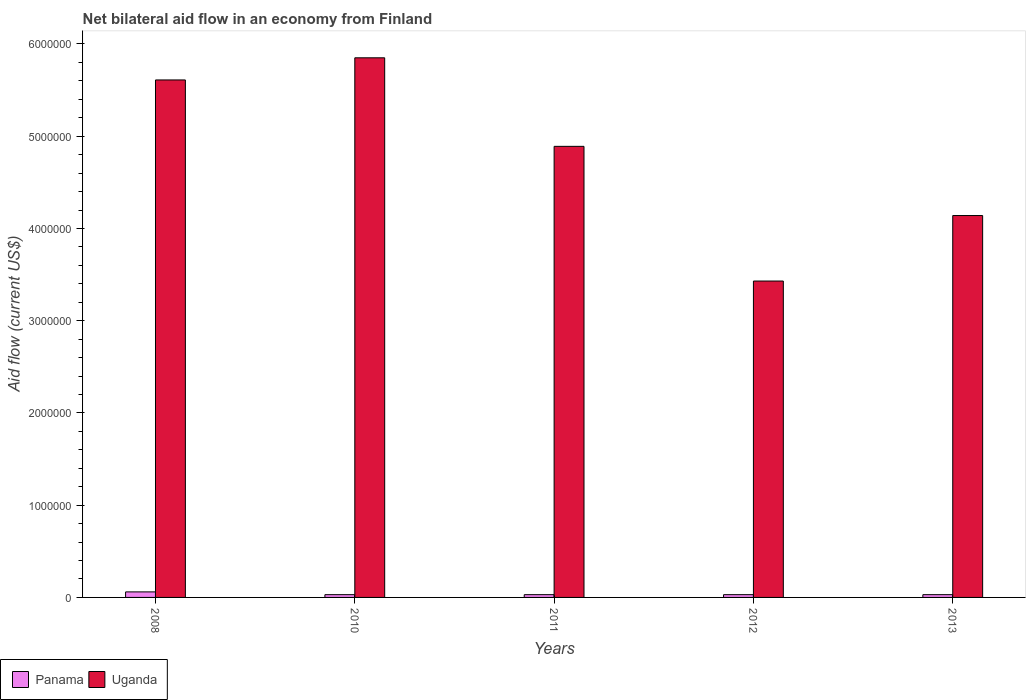How many different coloured bars are there?
Offer a very short reply. 2. How many groups of bars are there?
Ensure brevity in your answer.  5. Are the number of bars per tick equal to the number of legend labels?
Make the answer very short. Yes. How many bars are there on the 2nd tick from the right?
Provide a short and direct response. 2. What is the net bilateral aid flow in Uganda in 2011?
Provide a succinct answer. 4.89e+06. Across all years, what is the maximum net bilateral aid flow in Panama?
Make the answer very short. 6.00e+04. Across all years, what is the minimum net bilateral aid flow in Uganda?
Offer a very short reply. 3.43e+06. In which year was the net bilateral aid flow in Uganda minimum?
Your answer should be compact. 2012. What is the total net bilateral aid flow in Uganda in the graph?
Provide a short and direct response. 2.39e+07. What is the difference between the net bilateral aid flow in Panama in 2011 and the net bilateral aid flow in Uganda in 2012?
Provide a succinct answer. -3.40e+06. What is the average net bilateral aid flow in Uganda per year?
Provide a succinct answer. 4.78e+06. In the year 2012, what is the difference between the net bilateral aid flow in Uganda and net bilateral aid flow in Panama?
Your answer should be very brief. 3.40e+06. In how many years, is the net bilateral aid flow in Uganda greater than 5400000 US$?
Offer a terse response. 2. What is the ratio of the net bilateral aid flow in Uganda in 2011 to that in 2012?
Offer a very short reply. 1.43. Is the net bilateral aid flow in Uganda in 2010 less than that in 2012?
Your answer should be compact. No. Is the difference between the net bilateral aid flow in Uganda in 2012 and 2013 greater than the difference between the net bilateral aid flow in Panama in 2012 and 2013?
Make the answer very short. No. What is the difference between the highest and the second highest net bilateral aid flow in Uganda?
Ensure brevity in your answer.  2.40e+05. In how many years, is the net bilateral aid flow in Uganda greater than the average net bilateral aid flow in Uganda taken over all years?
Your answer should be very brief. 3. What does the 2nd bar from the left in 2008 represents?
Offer a terse response. Uganda. What does the 1st bar from the right in 2012 represents?
Offer a terse response. Uganda. How many bars are there?
Give a very brief answer. 10. How many years are there in the graph?
Provide a succinct answer. 5. What is the difference between two consecutive major ticks on the Y-axis?
Make the answer very short. 1.00e+06. Are the values on the major ticks of Y-axis written in scientific E-notation?
Your response must be concise. No. Does the graph contain any zero values?
Provide a succinct answer. No. How are the legend labels stacked?
Keep it short and to the point. Horizontal. What is the title of the graph?
Give a very brief answer. Net bilateral aid flow in an economy from Finland. What is the label or title of the X-axis?
Keep it short and to the point. Years. What is the Aid flow (current US$) of Panama in 2008?
Your response must be concise. 6.00e+04. What is the Aid flow (current US$) of Uganda in 2008?
Ensure brevity in your answer.  5.61e+06. What is the Aid flow (current US$) of Panama in 2010?
Provide a succinct answer. 3.00e+04. What is the Aid flow (current US$) in Uganda in 2010?
Your answer should be compact. 5.85e+06. What is the Aid flow (current US$) in Uganda in 2011?
Give a very brief answer. 4.89e+06. What is the Aid flow (current US$) in Uganda in 2012?
Make the answer very short. 3.43e+06. What is the Aid flow (current US$) of Uganda in 2013?
Make the answer very short. 4.14e+06. Across all years, what is the maximum Aid flow (current US$) of Uganda?
Give a very brief answer. 5.85e+06. Across all years, what is the minimum Aid flow (current US$) in Panama?
Your answer should be compact. 3.00e+04. Across all years, what is the minimum Aid flow (current US$) in Uganda?
Provide a succinct answer. 3.43e+06. What is the total Aid flow (current US$) of Uganda in the graph?
Offer a very short reply. 2.39e+07. What is the difference between the Aid flow (current US$) of Panama in 2008 and that in 2010?
Ensure brevity in your answer.  3.00e+04. What is the difference between the Aid flow (current US$) of Uganda in 2008 and that in 2010?
Your answer should be very brief. -2.40e+05. What is the difference between the Aid flow (current US$) of Uganda in 2008 and that in 2011?
Give a very brief answer. 7.20e+05. What is the difference between the Aid flow (current US$) in Panama in 2008 and that in 2012?
Your answer should be compact. 3.00e+04. What is the difference between the Aid flow (current US$) in Uganda in 2008 and that in 2012?
Your response must be concise. 2.18e+06. What is the difference between the Aid flow (current US$) in Uganda in 2008 and that in 2013?
Your response must be concise. 1.47e+06. What is the difference between the Aid flow (current US$) in Uganda in 2010 and that in 2011?
Make the answer very short. 9.60e+05. What is the difference between the Aid flow (current US$) of Panama in 2010 and that in 2012?
Your response must be concise. 0. What is the difference between the Aid flow (current US$) in Uganda in 2010 and that in 2012?
Make the answer very short. 2.42e+06. What is the difference between the Aid flow (current US$) in Panama in 2010 and that in 2013?
Your answer should be compact. 0. What is the difference between the Aid flow (current US$) in Uganda in 2010 and that in 2013?
Your answer should be very brief. 1.71e+06. What is the difference between the Aid flow (current US$) in Uganda in 2011 and that in 2012?
Offer a terse response. 1.46e+06. What is the difference between the Aid flow (current US$) in Panama in 2011 and that in 2013?
Keep it short and to the point. 0. What is the difference between the Aid flow (current US$) in Uganda in 2011 and that in 2013?
Ensure brevity in your answer.  7.50e+05. What is the difference between the Aid flow (current US$) of Uganda in 2012 and that in 2013?
Your answer should be very brief. -7.10e+05. What is the difference between the Aid flow (current US$) of Panama in 2008 and the Aid flow (current US$) of Uganda in 2010?
Provide a short and direct response. -5.79e+06. What is the difference between the Aid flow (current US$) in Panama in 2008 and the Aid flow (current US$) in Uganda in 2011?
Ensure brevity in your answer.  -4.83e+06. What is the difference between the Aid flow (current US$) of Panama in 2008 and the Aid flow (current US$) of Uganda in 2012?
Provide a short and direct response. -3.37e+06. What is the difference between the Aid flow (current US$) in Panama in 2008 and the Aid flow (current US$) in Uganda in 2013?
Your answer should be very brief. -4.08e+06. What is the difference between the Aid flow (current US$) of Panama in 2010 and the Aid flow (current US$) of Uganda in 2011?
Your answer should be very brief. -4.86e+06. What is the difference between the Aid flow (current US$) in Panama in 2010 and the Aid flow (current US$) in Uganda in 2012?
Offer a very short reply. -3.40e+06. What is the difference between the Aid flow (current US$) in Panama in 2010 and the Aid flow (current US$) in Uganda in 2013?
Provide a short and direct response. -4.11e+06. What is the difference between the Aid flow (current US$) in Panama in 2011 and the Aid flow (current US$) in Uganda in 2012?
Your answer should be compact. -3.40e+06. What is the difference between the Aid flow (current US$) of Panama in 2011 and the Aid flow (current US$) of Uganda in 2013?
Make the answer very short. -4.11e+06. What is the difference between the Aid flow (current US$) in Panama in 2012 and the Aid flow (current US$) in Uganda in 2013?
Keep it short and to the point. -4.11e+06. What is the average Aid flow (current US$) of Panama per year?
Offer a terse response. 3.60e+04. What is the average Aid flow (current US$) of Uganda per year?
Provide a succinct answer. 4.78e+06. In the year 2008, what is the difference between the Aid flow (current US$) in Panama and Aid flow (current US$) in Uganda?
Offer a very short reply. -5.55e+06. In the year 2010, what is the difference between the Aid flow (current US$) of Panama and Aid flow (current US$) of Uganda?
Your answer should be very brief. -5.82e+06. In the year 2011, what is the difference between the Aid flow (current US$) in Panama and Aid flow (current US$) in Uganda?
Your response must be concise. -4.86e+06. In the year 2012, what is the difference between the Aid flow (current US$) in Panama and Aid flow (current US$) in Uganda?
Offer a very short reply. -3.40e+06. In the year 2013, what is the difference between the Aid flow (current US$) in Panama and Aid flow (current US$) in Uganda?
Offer a terse response. -4.11e+06. What is the ratio of the Aid flow (current US$) in Uganda in 2008 to that in 2011?
Offer a terse response. 1.15. What is the ratio of the Aid flow (current US$) of Panama in 2008 to that in 2012?
Provide a short and direct response. 2. What is the ratio of the Aid flow (current US$) of Uganda in 2008 to that in 2012?
Your response must be concise. 1.64. What is the ratio of the Aid flow (current US$) of Uganda in 2008 to that in 2013?
Offer a very short reply. 1.36. What is the ratio of the Aid flow (current US$) in Panama in 2010 to that in 2011?
Your response must be concise. 1. What is the ratio of the Aid flow (current US$) in Uganda in 2010 to that in 2011?
Your answer should be compact. 1.2. What is the ratio of the Aid flow (current US$) in Panama in 2010 to that in 2012?
Provide a short and direct response. 1. What is the ratio of the Aid flow (current US$) in Uganda in 2010 to that in 2012?
Offer a terse response. 1.71. What is the ratio of the Aid flow (current US$) in Uganda in 2010 to that in 2013?
Your answer should be compact. 1.41. What is the ratio of the Aid flow (current US$) of Panama in 2011 to that in 2012?
Give a very brief answer. 1. What is the ratio of the Aid flow (current US$) of Uganda in 2011 to that in 2012?
Provide a short and direct response. 1.43. What is the ratio of the Aid flow (current US$) of Uganda in 2011 to that in 2013?
Your response must be concise. 1.18. What is the ratio of the Aid flow (current US$) of Panama in 2012 to that in 2013?
Your answer should be very brief. 1. What is the ratio of the Aid flow (current US$) in Uganda in 2012 to that in 2013?
Your answer should be very brief. 0.83. What is the difference between the highest and the lowest Aid flow (current US$) of Panama?
Your response must be concise. 3.00e+04. What is the difference between the highest and the lowest Aid flow (current US$) of Uganda?
Ensure brevity in your answer.  2.42e+06. 